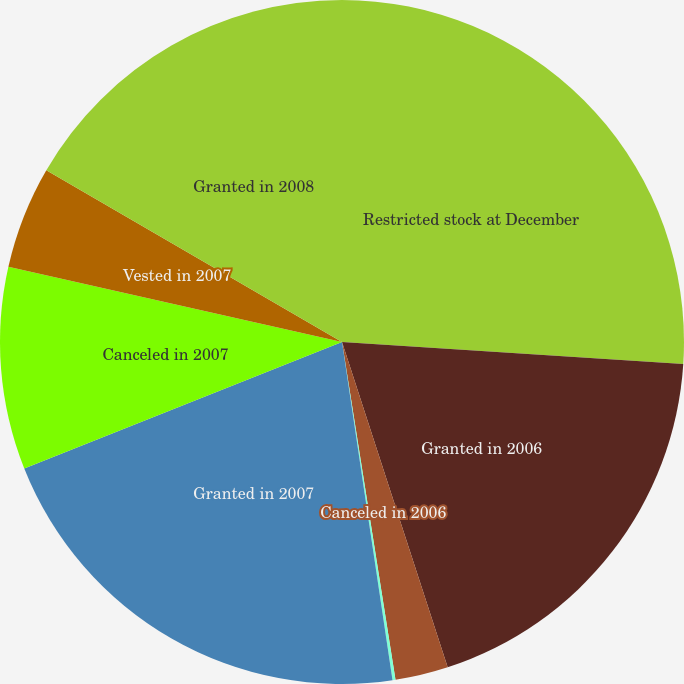<chart> <loc_0><loc_0><loc_500><loc_500><pie_chart><fcel>Restricted stock at December<fcel>Granted in 2006<fcel>Canceled in 2006<fcel>Vested in 2006<fcel>Granted in 2007<fcel>Canceled in 2007<fcel>Vested in 2007<fcel>Granted in 2008<nl><fcel>26.03%<fcel>18.97%<fcel>2.5%<fcel>0.14%<fcel>21.33%<fcel>9.56%<fcel>4.85%<fcel>16.62%<nl></chart> 